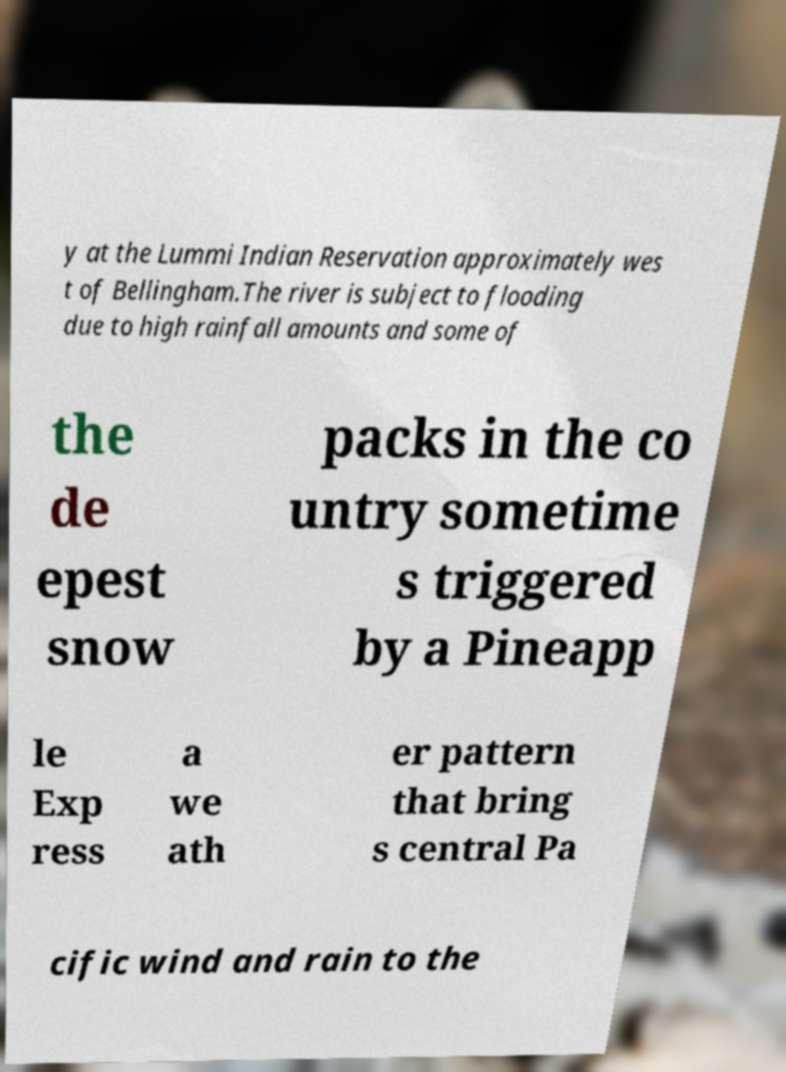Could you extract and type out the text from this image? y at the Lummi Indian Reservation approximately wes t of Bellingham.The river is subject to flooding due to high rainfall amounts and some of the de epest snow packs in the co untry sometime s triggered by a Pineapp le Exp ress a we ath er pattern that bring s central Pa cific wind and rain to the 